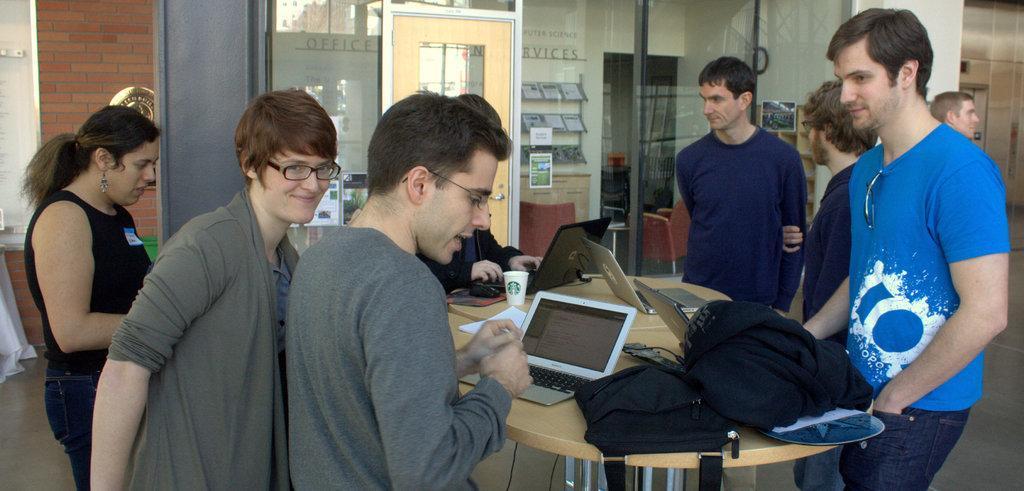Describe this image in one or two sentences. In this image we can see a group of people standing on the ground. In the foreground of the image we can see some laptops, mouse, bag, cup and some clothes placed on the table. In the background, we can see some books in the racks, posters and some glass doors. 